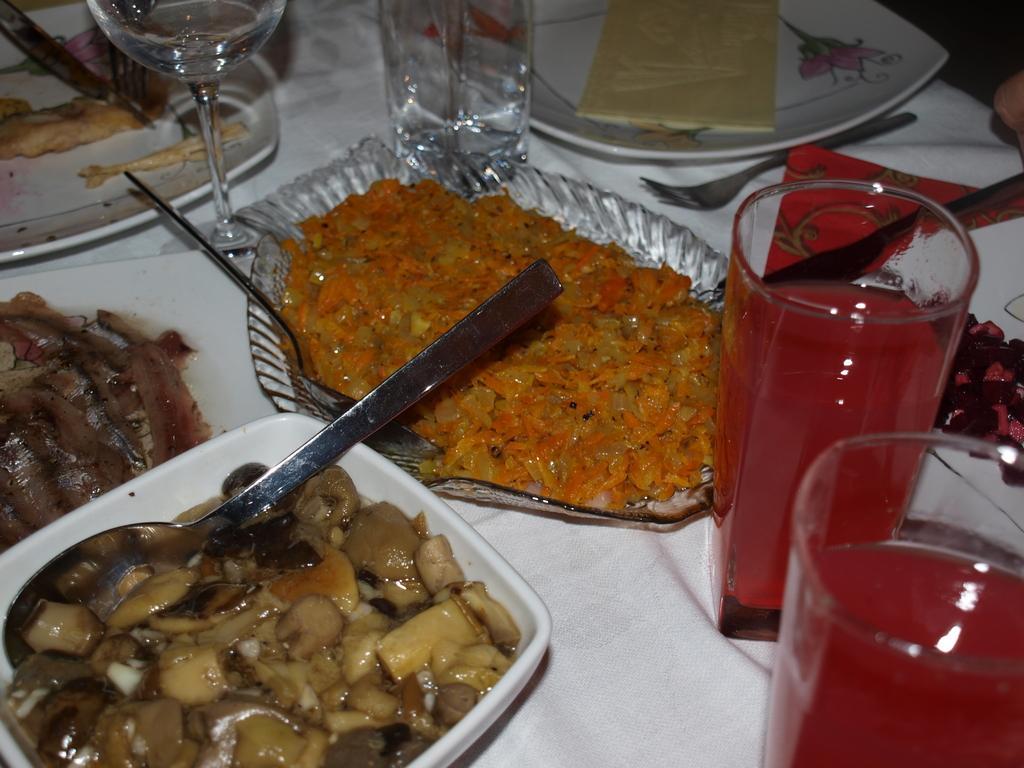Could you give a brief overview of what you see in this image? In this image there are few plates, glasses and a bowl are on the table. Plates and a bowl are having some food in it. Left bottom there is a bowl, having some food and a spoon in it. Glasses are filled with drink. Right side there is a fork on the table. 